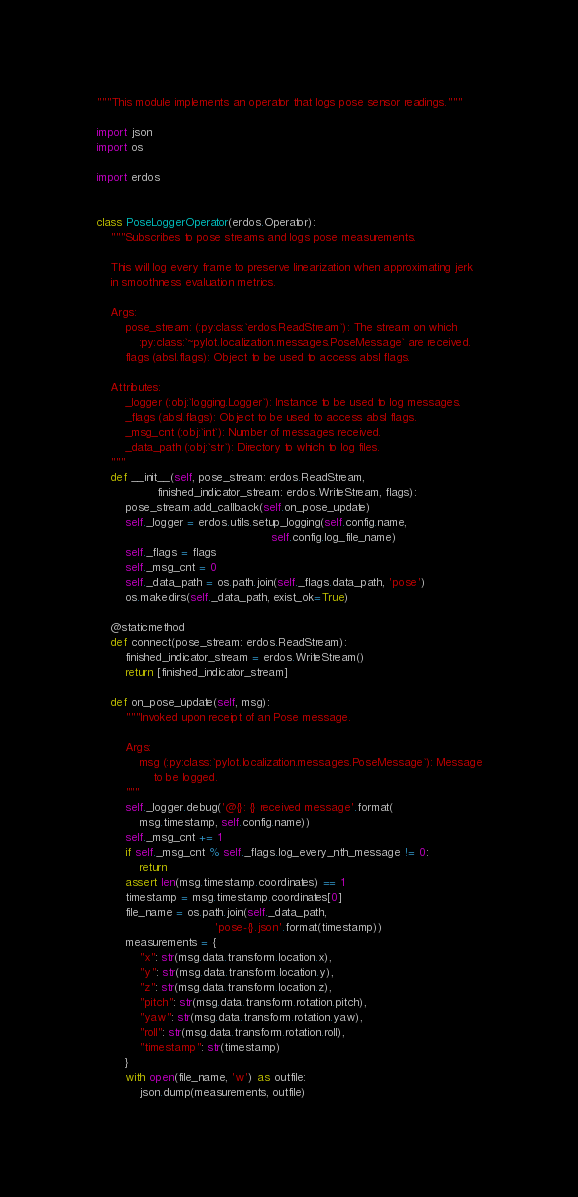<code> <loc_0><loc_0><loc_500><loc_500><_Python_>"""This module implements an operator that logs pose sensor readings."""

import json
import os

import erdos


class PoseLoggerOperator(erdos.Operator):
    """Subscribes to pose streams and logs pose measurements.

    This will log every frame to preserve linearization when approximating jerk
    in smoothness evaluation metrics.

    Args:
        pose_stream: (:py:class:`erdos.ReadStream`): The stream on which
            :py:class:`~pylot.localization.messages.PoseMessage` are received.
        flags (absl.flags): Object to be used to access absl flags.

    Attributes:
        _logger (:obj:`logging.Logger`): Instance to be used to log messages.
        _flags (absl.flags): Object to be used to access absl flags.
        _msg_cnt (:obj:`int`): Number of messages received.
        _data_path (:obj:`str`): Directory to which to log files.
    """
    def __init__(self, pose_stream: erdos.ReadStream,
                 finished_indicator_stream: erdos.WriteStream, flags):
        pose_stream.add_callback(self.on_pose_update)
        self._logger = erdos.utils.setup_logging(self.config.name,
                                                 self.config.log_file_name)
        self._flags = flags
        self._msg_cnt = 0
        self._data_path = os.path.join(self._flags.data_path, 'pose')
        os.makedirs(self._data_path, exist_ok=True)

    @staticmethod
    def connect(pose_stream: erdos.ReadStream):
        finished_indicator_stream = erdos.WriteStream()
        return [finished_indicator_stream]

    def on_pose_update(self, msg):
        """Invoked upon receipt of an Pose message.

        Args:
            msg (:py:class:`pylot.localization.messages.PoseMessage`): Message
                to be logged.
        """
        self._logger.debug('@{}: {} received message'.format(
            msg.timestamp, self.config.name))
        self._msg_cnt += 1
        if self._msg_cnt % self._flags.log_every_nth_message != 0:
            return
        assert len(msg.timestamp.coordinates) == 1
        timestamp = msg.timestamp.coordinates[0]
        file_name = os.path.join(self._data_path,
                                 'pose-{}.json'.format(timestamp))
        measurements = {
            "x": str(msg.data.transform.location.x),
            "y": str(msg.data.transform.location.y),
            "z": str(msg.data.transform.location.z),
            "pitch": str(msg.data.transform.rotation.pitch),
            "yaw": str(msg.data.transform.rotation.yaw),
            "roll": str(msg.data.transform.rotation.roll),
            "timestamp": str(timestamp)
        }
        with open(file_name, 'w') as outfile:
            json.dump(measurements, outfile)
</code> 